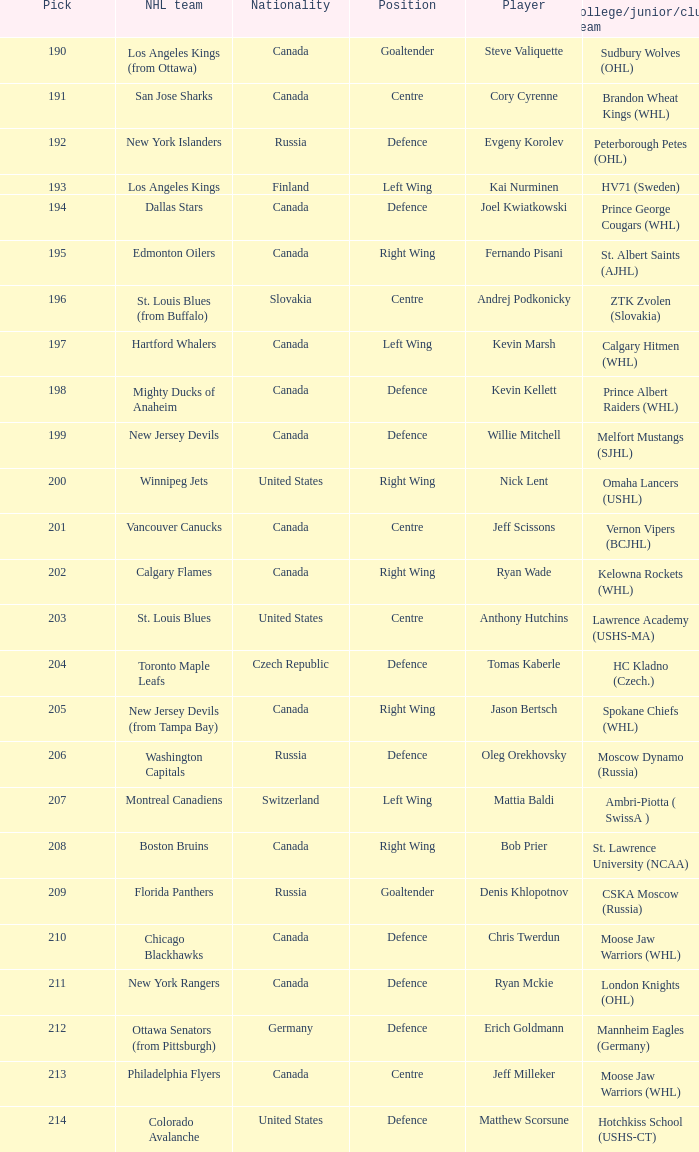Name the number of nationalities for ryan mckie 1.0. 